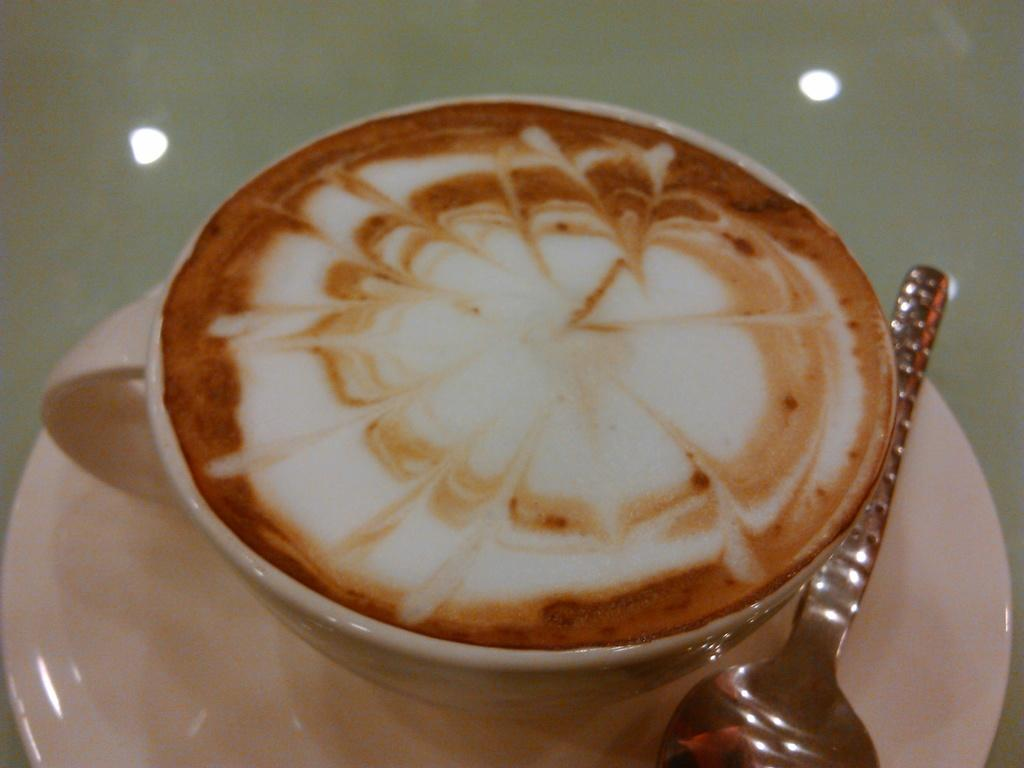What is present on the surface beneath the cup in the image? The cup is on a saucer in the image. What object is used for stirring or scooping in the image? There is a spoon in the image. What can be observed about the liquid in the cup? The liquid in the cup has white and brown colors. What type of grain is being selected in the image? There is no grain or selection process depicted in the image; it features a cup, saucer, spoon, and a liquid with white and brown colors. 